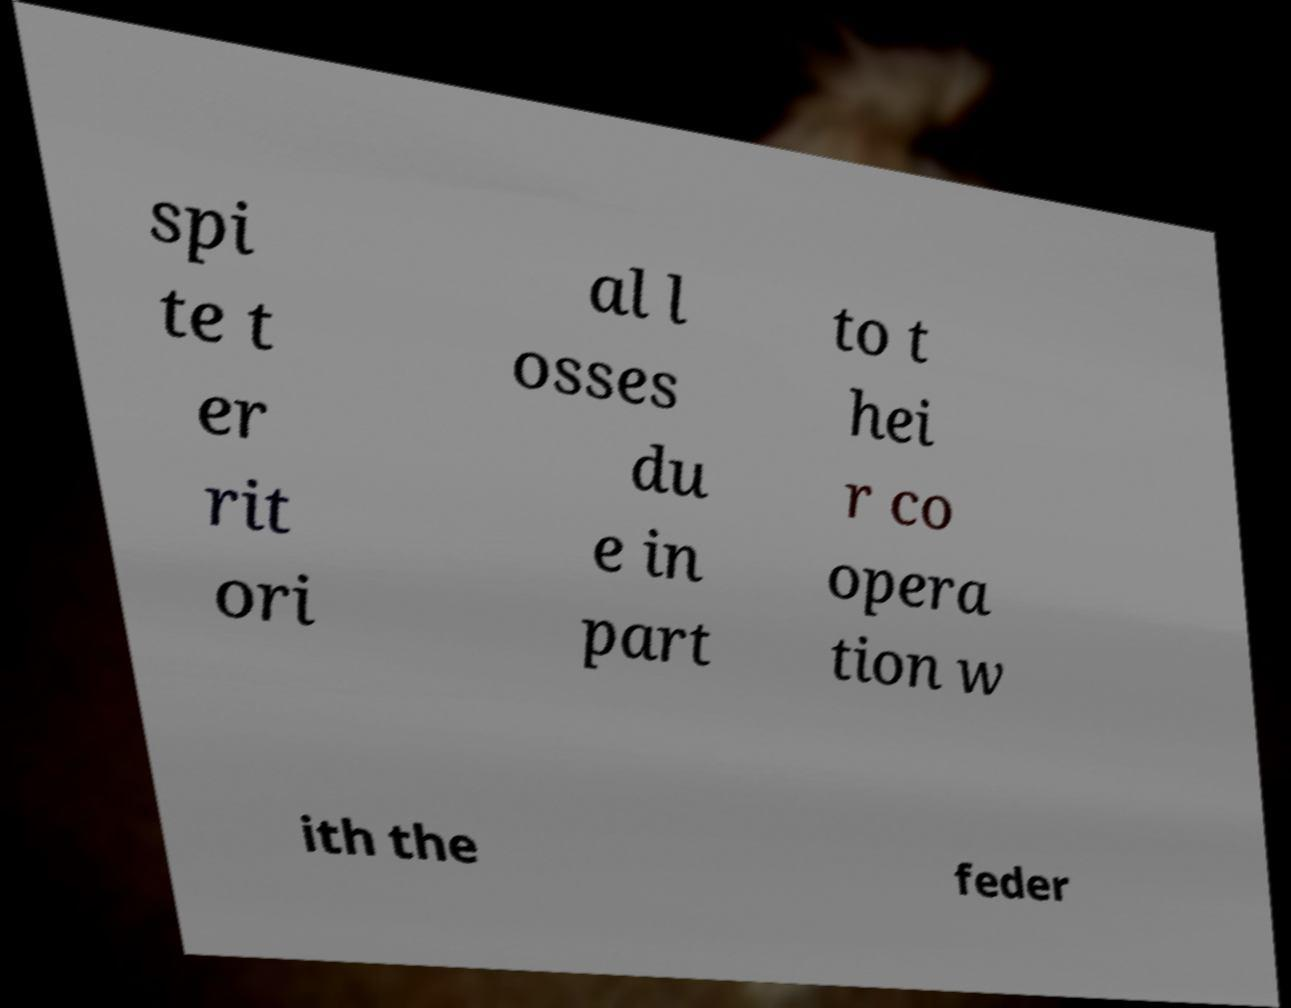Please identify and transcribe the text found in this image. spi te t er rit ori al l osses du e in part to t hei r co opera tion w ith the feder 